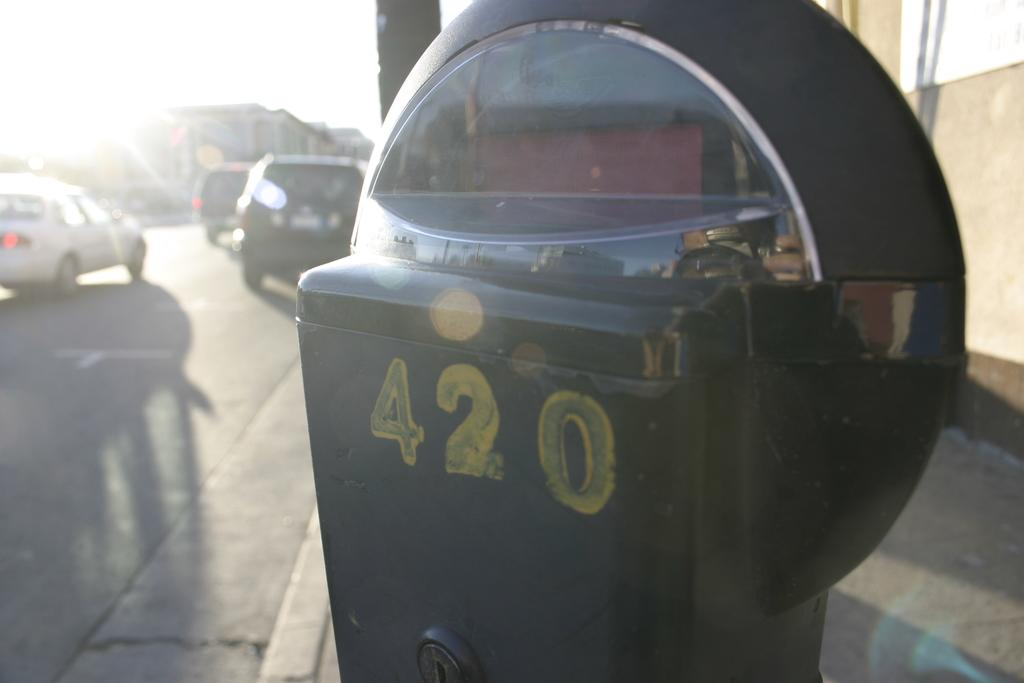<image>
Create a compact narrative representing the image presented. Black parking meter that says 420 in yellow paint. 